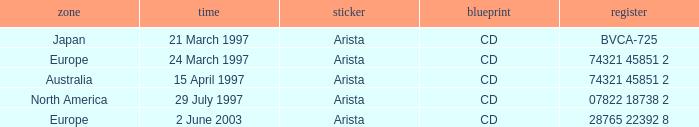What is written on the label having the date 29th july 1997? Arista. 